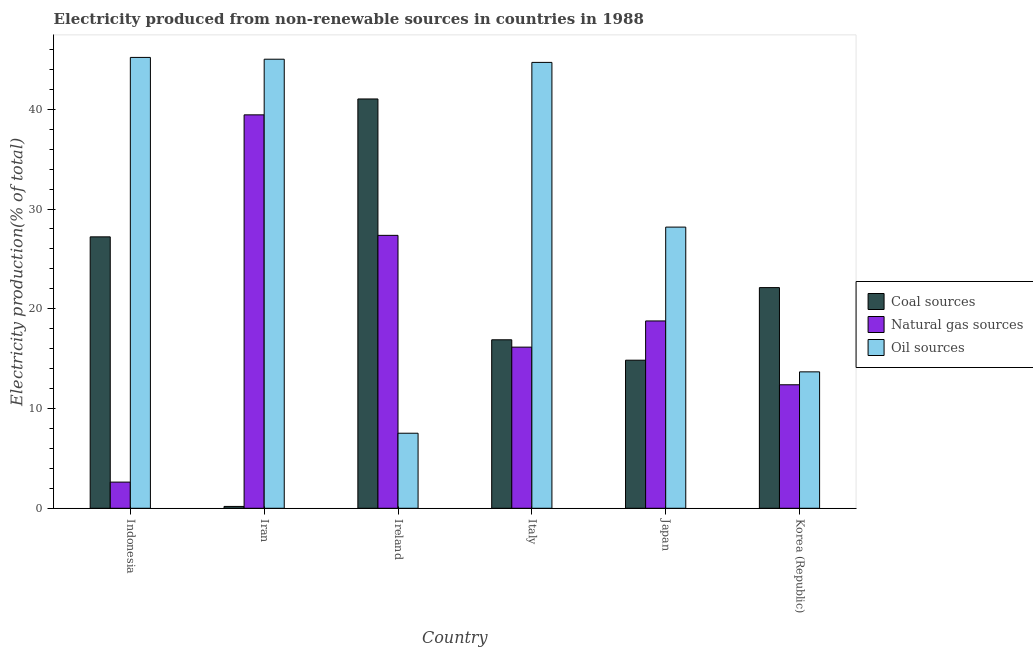How many groups of bars are there?
Ensure brevity in your answer.  6. Are the number of bars per tick equal to the number of legend labels?
Give a very brief answer. Yes. What is the percentage of electricity produced by coal in Korea (Republic)?
Offer a very short reply. 22.12. Across all countries, what is the maximum percentage of electricity produced by natural gas?
Keep it short and to the point. 39.44. Across all countries, what is the minimum percentage of electricity produced by natural gas?
Provide a succinct answer. 2.62. In which country was the percentage of electricity produced by natural gas maximum?
Provide a succinct answer. Iran. In which country was the percentage of electricity produced by coal minimum?
Your response must be concise. Iran. What is the total percentage of electricity produced by coal in the graph?
Your answer should be compact. 122.28. What is the difference between the percentage of electricity produced by natural gas in Ireland and that in Japan?
Provide a short and direct response. 8.58. What is the difference between the percentage of electricity produced by natural gas in Japan and the percentage of electricity produced by coal in Ireland?
Your answer should be compact. -22.25. What is the average percentage of electricity produced by coal per country?
Offer a very short reply. 20.38. What is the difference between the percentage of electricity produced by coal and percentage of electricity produced by oil sources in Japan?
Give a very brief answer. -13.34. What is the ratio of the percentage of electricity produced by natural gas in Ireland to that in Korea (Republic)?
Provide a succinct answer. 2.21. Is the difference between the percentage of electricity produced by oil sources in Ireland and Korea (Republic) greater than the difference between the percentage of electricity produced by natural gas in Ireland and Korea (Republic)?
Offer a terse response. No. What is the difference between the highest and the second highest percentage of electricity produced by coal?
Keep it short and to the point. 13.82. What is the difference between the highest and the lowest percentage of electricity produced by oil sources?
Keep it short and to the point. 37.67. Is the sum of the percentage of electricity produced by natural gas in Italy and Japan greater than the maximum percentage of electricity produced by coal across all countries?
Give a very brief answer. No. What does the 2nd bar from the left in Italy represents?
Provide a succinct answer. Natural gas sources. What does the 2nd bar from the right in Indonesia represents?
Offer a very short reply. Natural gas sources. Is it the case that in every country, the sum of the percentage of electricity produced by coal and percentage of electricity produced by natural gas is greater than the percentage of electricity produced by oil sources?
Your answer should be very brief. No. How many bars are there?
Offer a very short reply. 18. Are all the bars in the graph horizontal?
Provide a short and direct response. No. What is the difference between two consecutive major ticks on the Y-axis?
Your answer should be very brief. 10. Are the values on the major ticks of Y-axis written in scientific E-notation?
Offer a very short reply. No. Does the graph contain grids?
Your response must be concise. No. Where does the legend appear in the graph?
Ensure brevity in your answer.  Center right. How many legend labels are there?
Offer a very short reply. 3. What is the title of the graph?
Your answer should be very brief. Electricity produced from non-renewable sources in countries in 1988. What is the label or title of the X-axis?
Ensure brevity in your answer.  Country. What is the label or title of the Y-axis?
Give a very brief answer. Electricity production(% of total). What is the Electricity production(% of total) in Coal sources in Indonesia?
Offer a very short reply. 27.21. What is the Electricity production(% of total) in Natural gas sources in Indonesia?
Your response must be concise. 2.62. What is the Electricity production(% of total) of Oil sources in Indonesia?
Keep it short and to the point. 45.2. What is the Electricity production(% of total) of Coal sources in Iran?
Your answer should be compact. 0.18. What is the Electricity production(% of total) of Natural gas sources in Iran?
Your answer should be compact. 39.44. What is the Electricity production(% of total) of Oil sources in Iran?
Ensure brevity in your answer.  45.02. What is the Electricity production(% of total) of Coal sources in Ireland?
Provide a short and direct response. 41.03. What is the Electricity production(% of total) in Natural gas sources in Ireland?
Offer a terse response. 27.36. What is the Electricity production(% of total) of Oil sources in Ireland?
Keep it short and to the point. 7.52. What is the Electricity production(% of total) in Coal sources in Italy?
Provide a short and direct response. 16.89. What is the Electricity production(% of total) in Natural gas sources in Italy?
Provide a succinct answer. 16.15. What is the Electricity production(% of total) in Oil sources in Italy?
Provide a short and direct response. 44.7. What is the Electricity production(% of total) in Coal sources in Japan?
Provide a succinct answer. 14.84. What is the Electricity production(% of total) in Natural gas sources in Japan?
Ensure brevity in your answer.  18.78. What is the Electricity production(% of total) of Oil sources in Japan?
Offer a very short reply. 28.19. What is the Electricity production(% of total) in Coal sources in Korea (Republic)?
Ensure brevity in your answer.  22.12. What is the Electricity production(% of total) of Natural gas sources in Korea (Republic)?
Provide a short and direct response. 12.38. What is the Electricity production(% of total) in Oil sources in Korea (Republic)?
Your answer should be compact. 13.68. Across all countries, what is the maximum Electricity production(% of total) of Coal sources?
Offer a terse response. 41.03. Across all countries, what is the maximum Electricity production(% of total) of Natural gas sources?
Make the answer very short. 39.44. Across all countries, what is the maximum Electricity production(% of total) of Oil sources?
Keep it short and to the point. 45.2. Across all countries, what is the minimum Electricity production(% of total) in Coal sources?
Offer a terse response. 0.18. Across all countries, what is the minimum Electricity production(% of total) of Natural gas sources?
Offer a terse response. 2.62. Across all countries, what is the minimum Electricity production(% of total) in Oil sources?
Offer a terse response. 7.52. What is the total Electricity production(% of total) in Coal sources in the graph?
Offer a very short reply. 122.28. What is the total Electricity production(% of total) in Natural gas sources in the graph?
Keep it short and to the point. 116.73. What is the total Electricity production(% of total) of Oil sources in the graph?
Give a very brief answer. 184.29. What is the difference between the Electricity production(% of total) of Coal sources in Indonesia and that in Iran?
Provide a short and direct response. 27.02. What is the difference between the Electricity production(% of total) in Natural gas sources in Indonesia and that in Iran?
Provide a succinct answer. -36.82. What is the difference between the Electricity production(% of total) in Oil sources in Indonesia and that in Iran?
Provide a succinct answer. 0.18. What is the difference between the Electricity production(% of total) of Coal sources in Indonesia and that in Ireland?
Provide a succinct answer. -13.82. What is the difference between the Electricity production(% of total) of Natural gas sources in Indonesia and that in Ireland?
Your response must be concise. -24.74. What is the difference between the Electricity production(% of total) in Oil sources in Indonesia and that in Ireland?
Offer a terse response. 37.67. What is the difference between the Electricity production(% of total) in Coal sources in Indonesia and that in Italy?
Ensure brevity in your answer.  10.32. What is the difference between the Electricity production(% of total) in Natural gas sources in Indonesia and that in Italy?
Your response must be concise. -13.53. What is the difference between the Electricity production(% of total) in Oil sources in Indonesia and that in Italy?
Offer a very short reply. 0.5. What is the difference between the Electricity production(% of total) in Coal sources in Indonesia and that in Japan?
Provide a short and direct response. 12.37. What is the difference between the Electricity production(% of total) in Natural gas sources in Indonesia and that in Japan?
Your answer should be compact. -16.16. What is the difference between the Electricity production(% of total) of Oil sources in Indonesia and that in Japan?
Provide a succinct answer. 17.01. What is the difference between the Electricity production(% of total) of Coal sources in Indonesia and that in Korea (Republic)?
Your answer should be compact. 5.09. What is the difference between the Electricity production(% of total) in Natural gas sources in Indonesia and that in Korea (Republic)?
Keep it short and to the point. -9.76. What is the difference between the Electricity production(% of total) of Oil sources in Indonesia and that in Korea (Republic)?
Ensure brevity in your answer.  31.52. What is the difference between the Electricity production(% of total) in Coal sources in Iran and that in Ireland?
Keep it short and to the point. -40.85. What is the difference between the Electricity production(% of total) in Natural gas sources in Iran and that in Ireland?
Ensure brevity in your answer.  12.08. What is the difference between the Electricity production(% of total) of Oil sources in Iran and that in Ireland?
Provide a short and direct response. 37.49. What is the difference between the Electricity production(% of total) in Coal sources in Iran and that in Italy?
Offer a terse response. -16.71. What is the difference between the Electricity production(% of total) in Natural gas sources in Iran and that in Italy?
Give a very brief answer. 23.28. What is the difference between the Electricity production(% of total) in Oil sources in Iran and that in Italy?
Ensure brevity in your answer.  0.32. What is the difference between the Electricity production(% of total) of Coal sources in Iran and that in Japan?
Your answer should be very brief. -14.66. What is the difference between the Electricity production(% of total) in Natural gas sources in Iran and that in Japan?
Your answer should be compact. 20.66. What is the difference between the Electricity production(% of total) in Oil sources in Iran and that in Japan?
Offer a terse response. 16.83. What is the difference between the Electricity production(% of total) of Coal sources in Iran and that in Korea (Republic)?
Provide a succinct answer. -21.94. What is the difference between the Electricity production(% of total) of Natural gas sources in Iran and that in Korea (Republic)?
Give a very brief answer. 27.06. What is the difference between the Electricity production(% of total) in Oil sources in Iran and that in Korea (Republic)?
Your answer should be compact. 31.34. What is the difference between the Electricity production(% of total) in Coal sources in Ireland and that in Italy?
Provide a succinct answer. 24.14. What is the difference between the Electricity production(% of total) in Natural gas sources in Ireland and that in Italy?
Give a very brief answer. 11.21. What is the difference between the Electricity production(% of total) in Oil sources in Ireland and that in Italy?
Provide a short and direct response. -37.17. What is the difference between the Electricity production(% of total) of Coal sources in Ireland and that in Japan?
Give a very brief answer. 26.19. What is the difference between the Electricity production(% of total) in Natural gas sources in Ireland and that in Japan?
Ensure brevity in your answer.  8.58. What is the difference between the Electricity production(% of total) in Oil sources in Ireland and that in Japan?
Provide a succinct answer. -20.66. What is the difference between the Electricity production(% of total) of Coal sources in Ireland and that in Korea (Republic)?
Your answer should be very brief. 18.91. What is the difference between the Electricity production(% of total) in Natural gas sources in Ireland and that in Korea (Republic)?
Your response must be concise. 14.98. What is the difference between the Electricity production(% of total) of Oil sources in Ireland and that in Korea (Republic)?
Offer a very short reply. -6.15. What is the difference between the Electricity production(% of total) of Coal sources in Italy and that in Japan?
Provide a short and direct response. 2.05. What is the difference between the Electricity production(% of total) in Natural gas sources in Italy and that in Japan?
Ensure brevity in your answer.  -2.62. What is the difference between the Electricity production(% of total) in Oil sources in Italy and that in Japan?
Offer a terse response. 16.51. What is the difference between the Electricity production(% of total) of Coal sources in Italy and that in Korea (Republic)?
Give a very brief answer. -5.23. What is the difference between the Electricity production(% of total) of Natural gas sources in Italy and that in Korea (Republic)?
Offer a terse response. 3.77. What is the difference between the Electricity production(% of total) of Oil sources in Italy and that in Korea (Republic)?
Give a very brief answer. 31.02. What is the difference between the Electricity production(% of total) in Coal sources in Japan and that in Korea (Republic)?
Ensure brevity in your answer.  -7.28. What is the difference between the Electricity production(% of total) of Natural gas sources in Japan and that in Korea (Republic)?
Offer a very short reply. 6.4. What is the difference between the Electricity production(% of total) in Oil sources in Japan and that in Korea (Republic)?
Provide a short and direct response. 14.51. What is the difference between the Electricity production(% of total) in Coal sources in Indonesia and the Electricity production(% of total) in Natural gas sources in Iran?
Offer a very short reply. -12.23. What is the difference between the Electricity production(% of total) in Coal sources in Indonesia and the Electricity production(% of total) in Oil sources in Iran?
Make the answer very short. -17.81. What is the difference between the Electricity production(% of total) of Natural gas sources in Indonesia and the Electricity production(% of total) of Oil sources in Iran?
Keep it short and to the point. -42.39. What is the difference between the Electricity production(% of total) of Coal sources in Indonesia and the Electricity production(% of total) of Natural gas sources in Ireland?
Your answer should be compact. -0.15. What is the difference between the Electricity production(% of total) in Coal sources in Indonesia and the Electricity production(% of total) in Oil sources in Ireland?
Your response must be concise. 19.69. What is the difference between the Electricity production(% of total) of Natural gas sources in Indonesia and the Electricity production(% of total) of Oil sources in Ireland?
Keep it short and to the point. -4.9. What is the difference between the Electricity production(% of total) of Coal sources in Indonesia and the Electricity production(% of total) of Natural gas sources in Italy?
Give a very brief answer. 11.05. What is the difference between the Electricity production(% of total) in Coal sources in Indonesia and the Electricity production(% of total) in Oil sources in Italy?
Provide a succinct answer. -17.49. What is the difference between the Electricity production(% of total) of Natural gas sources in Indonesia and the Electricity production(% of total) of Oil sources in Italy?
Give a very brief answer. -42.07. What is the difference between the Electricity production(% of total) in Coal sources in Indonesia and the Electricity production(% of total) in Natural gas sources in Japan?
Provide a short and direct response. 8.43. What is the difference between the Electricity production(% of total) in Coal sources in Indonesia and the Electricity production(% of total) in Oil sources in Japan?
Provide a succinct answer. -0.98. What is the difference between the Electricity production(% of total) in Natural gas sources in Indonesia and the Electricity production(% of total) in Oil sources in Japan?
Ensure brevity in your answer.  -25.56. What is the difference between the Electricity production(% of total) in Coal sources in Indonesia and the Electricity production(% of total) in Natural gas sources in Korea (Republic)?
Give a very brief answer. 14.83. What is the difference between the Electricity production(% of total) of Coal sources in Indonesia and the Electricity production(% of total) of Oil sources in Korea (Republic)?
Provide a succinct answer. 13.53. What is the difference between the Electricity production(% of total) in Natural gas sources in Indonesia and the Electricity production(% of total) in Oil sources in Korea (Republic)?
Give a very brief answer. -11.05. What is the difference between the Electricity production(% of total) in Coal sources in Iran and the Electricity production(% of total) in Natural gas sources in Ireland?
Make the answer very short. -27.17. What is the difference between the Electricity production(% of total) in Coal sources in Iran and the Electricity production(% of total) in Oil sources in Ireland?
Make the answer very short. -7.34. What is the difference between the Electricity production(% of total) in Natural gas sources in Iran and the Electricity production(% of total) in Oil sources in Ireland?
Make the answer very short. 31.92. What is the difference between the Electricity production(% of total) in Coal sources in Iran and the Electricity production(% of total) in Natural gas sources in Italy?
Make the answer very short. -15.97. What is the difference between the Electricity production(% of total) in Coal sources in Iran and the Electricity production(% of total) in Oil sources in Italy?
Give a very brief answer. -44.51. What is the difference between the Electricity production(% of total) in Natural gas sources in Iran and the Electricity production(% of total) in Oil sources in Italy?
Make the answer very short. -5.26. What is the difference between the Electricity production(% of total) in Coal sources in Iran and the Electricity production(% of total) in Natural gas sources in Japan?
Keep it short and to the point. -18.59. What is the difference between the Electricity production(% of total) of Coal sources in Iran and the Electricity production(% of total) of Oil sources in Japan?
Provide a succinct answer. -28. What is the difference between the Electricity production(% of total) in Natural gas sources in Iran and the Electricity production(% of total) in Oil sources in Japan?
Ensure brevity in your answer.  11.25. What is the difference between the Electricity production(% of total) in Coal sources in Iran and the Electricity production(% of total) in Natural gas sources in Korea (Republic)?
Offer a terse response. -12.2. What is the difference between the Electricity production(% of total) of Coal sources in Iran and the Electricity production(% of total) of Oil sources in Korea (Republic)?
Ensure brevity in your answer.  -13.49. What is the difference between the Electricity production(% of total) of Natural gas sources in Iran and the Electricity production(% of total) of Oil sources in Korea (Republic)?
Your answer should be very brief. 25.76. What is the difference between the Electricity production(% of total) of Coal sources in Ireland and the Electricity production(% of total) of Natural gas sources in Italy?
Give a very brief answer. 24.88. What is the difference between the Electricity production(% of total) in Coal sources in Ireland and the Electricity production(% of total) in Oil sources in Italy?
Keep it short and to the point. -3.67. What is the difference between the Electricity production(% of total) of Natural gas sources in Ireland and the Electricity production(% of total) of Oil sources in Italy?
Ensure brevity in your answer.  -17.34. What is the difference between the Electricity production(% of total) of Coal sources in Ireland and the Electricity production(% of total) of Natural gas sources in Japan?
Keep it short and to the point. 22.25. What is the difference between the Electricity production(% of total) of Coal sources in Ireland and the Electricity production(% of total) of Oil sources in Japan?
Keep it short and to the point. 12.84. What is the difference between the Electricity production(% of total) in Natural gas sources in Ireland and the Electricity production(% of total) in Oil sources in Japan?
Your answer should be compact. -0.83. What is the difference between the Electricity production(% of total) of Coal sources in Ireland and the Electricity production(% of total) of Natural gas sources in Korea (Republic)?
Make the answer very short. 28.65. What is the difference between the Electricity production(% of total) in Coal sources in Ireland and the Electricity production(% of total) in Oil sources in Korea (Republic)?
Ensure brevity in your answer.  27.36. What is the difference between the Electricity production(% of total) in Natural gas sources in Ireland and the Electricity production(% of total) in Oil sources in Korea (Republic)?
Make the answer very short. 13.68. What is the difference between the Electricity production(% of total) of Coal sources in Italy and the Electricity production(% of total) of Natural gas sources in Japan?
Your answer should be very brief. -1.89. What is the difference between the Electricity production(% of total) in Coal sources in Italy and the Electricity production(% of total) in Oil sources in Japan?
Provide a succinct answer. -11.3. What is the difference between the Electricity production(% of total) in Natural gas sources in Italy and the Electricity production(% of total) in Oil sources in Japan?
Provide a succinct answer. -12.03. What is the difference between the Electricity production(% of total) in Coal sources in Italy and the Electricity production(% of total) in Natural gas sources in Korea (Republic)?
Provide a short and direct response. 4.51. What is the difference between the Electricity production(% of total) in Coal sources in Italy and the Electricity production(% of total) in Oil sources in Korea (Republic)?
Keep it short and to the point. 3.21. What is the difference between the Electricity production(% of total) in Natural gas sources in Italy and the Electricity production(% of total) in Oil sources in Korea (Republic)?
Offer a terse response. 2.48. What is the difference between the Electricity production(% of total) of Coal sources in Japan and the Electricity production(% of total) of Natural gas sources in Korea (Republic)?
Keep it short and to the point. 2.46. What is the difference between the Electricity production(% of total) in Coal sources in Japan and the Electricity production(% of total) in Oil sources in Korea (Republic)?
Keep it short and to the point. 1.17. What is the difference between the Electricity production(% of total) in Natural gas sources in Japan and the Electricity production(% of total) in Oil sources in Korea (Republic)?
Offer a terse response. 5.1. What is the average Electricity production(% of total) in Coal sources per country?
Provide a succinct answer. 20.38. What is the average Electricity production(% of total) in Natural gas sources per country?
Provide a short and direct response. 19.46. What is the average Electricity production(% of total) in Oil sources per country?
Your answer should be compact. 30.72. What is the difference between the Electricity production(% of total) of Coal sources and Electricity production(% of total) of Natural gas sources in Indonesia?
Keep it short and to the point. 24.59. What is the difference between the Electricity production(% of total) in Coal sources and Electricity production(% of total) in Oil sources in Indonesia?
Your response must be concise. -17.99. What is the difference between the Electricity production(% of total) in Natural gas sources and Electricity production(% of total) in Oil sources in Indonesia?
Your response must be concise. -42.57. What is the difference between the Electricity production(% of total) in Coal sources and Electricity production(% of total) in Natural gas sources in Iran?
Your answer should be compact. -39.25. What is the difference between the Electricity production(% of total) in Coal sources and Electricity production(% of total) in Oil sources in Iran?
Give a very brief answer. -44.83. What is the difference between the Electricity production(% of total) in Natural gas sources and Electricity production(% of total) in Oil sources in Iran?
Offer a very short reply. -5.58. What is the difference between the Electricity production(% of total) of Coal sources and Electricity production(% of total) of Natural gas sources in Ireland?
Your answer should be compact. 13.67. What is the difference between the Electricity production(% of total) in Coal sources and Electricity production(% of total) in Oil sources in Ireland?
Keep it short and to the point. 33.51. What is the difference between the Electricity production(% of total) of Natural gas sources and Electricity production(% of total) of Oil sources in Ireland?
Offer a terse response. 19.84. What is the difference between the Electricity production(% of total) in Coal sources and Electricity production(% of total) in Natural gas sources in Italy?
Make the answer very short. 0.74. What is the difference between the Electricity production(% of total) of Coal sources and Electricity production(% of total) of Oil sources in Italy?
Your answer should be very brief. -27.81. What is the difference between the Electricity production(% of total) in Natural gas sources and Electricity production(% of total) in Oil sources in Italy?
Give a very brief answer. -28.54. What is the difference between the Electricity production(% of total) in Coal sources and Electricity production(% of total) in Natural gas sources in Japan?
Offer a terse response. -3.93. What is the difference between the Electricity production(% of total) of Coal sources and Electricity production(% of total) of Oil sources in Japan?
Give a very brief answer. -13.34. What is the difference between the Electricity production(% of total) of Natural gas sources and Electricity production(% of total) of Oil sources in Japan?
Provide a succinct answer. -9.41. What is the difference between the Electricity production(% of total) in Coal sources and Electricity production(% of total) in Natural gas sources in Korea (Republic)?
Your answer should be very brief. 9.74. What is the difference between the Electricity production(% of total) of Coal sources and Electricity production(% of total) of Oil sources in Korea (Republic)?
Your answer should be compact. 8.45. What is the difference between the Electricity production(% of total) of Natural gas sources and Electricity production(% of total) of Oil sources in Korea (Republic)?
Keep it short and to the point. -1.29. What is the ratio of the Electricity production(% of total) of Coal sources in Indonesia to that in Iran?
Offer a terse response. 147.18. What is the ratio of the Electricity production(% of total) in Natural gas sources in Indonesia to that in Iran?
Give a very brief answer. 0.07. What is the ratio of the Electricity production(% of total) of Coal sources in Indonesia to that in Ireland?
Provide a short and direct response. 0.66. What is the ratio of the Electricity production(% of total) in Natural gas sources in Indonesia to that in Ireland?
Offer a terse response. 0.1. What is the ratio of the Electricity production(% of total) of Oil sources in Indonesia to that in Ireland?
Provide a succinct answer. 6.01. What is the ratio of the Electricity production(% of total) in Coal sources in Indonesia to that in Italy?
Your answer should be compact. 1.61. What is the ratio of the Electricity production(% of total) in Natural gas sources in Indonesia to that in Italy?
Ensure brevity in your answer.  0.16. What is the ratio of the Electricity production(% of total) of Oil sources in Indonesia to that in Italy?
Ensure brevity in your answer.  1.01. What is the ratio of the Electricity production(% of total) of Coal sources in Indonesia to that in Japan?
Make the answer very short. 1.83. What is the ratio of the Electricity production(% of total) of Natural gas sources in Indonesia to that in Japan?
Offer a terse response. 0.14. What is the ratio of the Electricity production(% of total) of Oil sources in Indonesia to that in Japan?
Make the answer very short. 1.6. What is the ratio of the Electricity production(% of total) of Coal sources in Indonesia to that in Korea (Republic)?
Keep it short and to the point. 1.23. What is the ratio of the Electricity production(% of total) in Natural gas sources in Indonesia to that in Korea (Republic)?
Ensure brevity in your answer.  0.21. What is the ratio of the Electricity production(% of total) of Oil sources in Indonesia to that in Korea (Republic)?
Your answer should be very brief. 3.31. What is the ratio of the Electricity production(% of total) in Coal sources in Iran to that in Ireland?
Offer a terse response. 0. What is the ratio of the Electricity production(% of total) of Natural gas sources in Iran to that in Ireland?
Make the answer very short. 1.44. What is the ratio of the Electricity production(% of total) in Oil sources in Iran to that in Ireland?
Ensure brevity in your answer.  5.98. What is the ratio of the Electricity production(% of total) in Coal sources in Iran to that in Italy?
Your answer should be compact. 0.01. What is the ratio of the Electricity production(% of total) of Natural gas sources in Iran to that in Italy?
Provide a succinct answer. 2.44. What is the ratio of the Electricity production(% of total) of Oil sources in Iran to that in Italy?
Ensure brevity in your answer.  1.01. What is the ratio of the Electricity production(% of total) in Coal sources in Iran to that in Japan?
Offer a terse response. 0.01. What is the ratio of the Electricity production(% of total) in Natural gas sources in Iran to that in Japan?
Make the answer very short. 2.1. What is the ratio of the Electricity production(% of total) in Oil sources in Iran to that in Japan?
Your answer should be compact. 1.6. What is the ratio of the Electricity production(% of total) of Coal sources in Iran to that in Korea (Republic)?
Offer a very short reply. 0.01. What is the ratio of the Electricity production(% of total) in Natural gas sources in Iran to that in Korea (Republic)?
Make the answer very short. 3.19. What is the ratio of the Electricity production(% of total) of Oil sources in Iran to that in Korea (Republic)?
Your answer should be very brief. 3.29. What is the ratio of the Electricity production(% of total) of Coal sources in Ireland to that in Italy?
Offer a very short reply. 2.43. What is the ratio of the Electricity production(% of total) in Natural gas sources in Ireland to that in Italy?
Keep it short and to the point. 1.69. What is the ratio of the Electricity production(% of total) of Oil sources in Ireland to that in Italy?
Offer a very short reply. 0.17. What is the ratio of the Electricity production(% of total) of Coal sources in Ireland to that in Japan?
Keep it short and to the point. 2.76. What is the ratio of the Electricity production(% of total) of Natural gas sources in Ireland to that in Japan?
Your answer should be very brief. 1.46. What is the ratio of the Electricity production(% of total) of Oil sources in Ireland to that in Japan?
Give a very brief answer. 0.27. What is the ratio of the Electricity production(% of total) in Coal sources in Ireland to that in Korea (Republic)?
Provide a short and direct response. 1.85. What is the ratio of the Electricity production(% of total) of Natural gas sources in Ireland to that in Korea (Republic)?
Make the answer very short. 2.21. What is the ratio of the Electricity production(% of total) in Oil sources in Ireland to that in Korea (Republic)?
Provide a short and direct response. 0.55. What is the ratio of the Electricity production(% of total) of Coal sources in Italy to that in Japan?
Provide a short and direct response. 1.14. What is the ratio of the Electricity production(% of total) in Natural gas sources in Italy to that in Japan?
Keep it short and to the point. 0.86. What is the ratio of the Electricity production(% of total) in Oil sources in Italy to that in Japan?
Provide a succinct answer. 1.59. What is the ratio of the Electricity production(% of total) in Coal sources in Italy to that in Korea (Republic)?
Provide a succinct answer. 0.76. What is the ratio of the Electricity production(% of total) in Natural gas sources in Italy to that in Korea (Republic)?
Offer a terse response. 1.3. What is the ratio of the Electricity production(% of total) of Oil sources in Italy to that in Korea (Republic)?
Give a very brief answer. 3.27. What is the ratio of the Electricity production(% of total) in Coal sources in Japan to that in Korea (Republic)?
Keep it short and to the point. 0.67. What is the ratio of the Electricity production(% of total) in Natural gas sources in Japan to that in Korea (Republic)?
Your answer should be very brief. 1.52. What is the ratio of the Electricity production(% of total) in Oil sources in Japan to that in Korea (Republic)?
Provide a succinct answer. 2.06. What is the difference between the highest and the second highest Electricity production(% of total) of Coal sources?
Ensure brevity in your answer.  13.82. What is the difference between the highest and the second highest Electricity production(% of total) in Natural gas sources?
Provide a short and direct response. 12.08. What is the difference between the highest and the second highest Electricity production(% of total) of Oil sources?
Ensure brevity in your answer.  0.18. What is the difference between the highest and the lowest Electricity production(% of total) in Coal sources?
Give a very brief answer. 40.85. What is the difference between the highest and the lowest Electricity production(% of total) in Natural gas sources?
Keep it short and to the point. 36.82. What is the difference between the highest and the lowest Electricity production(% of total) in Oil sources?
Keep it short and to the point. 37.67. 